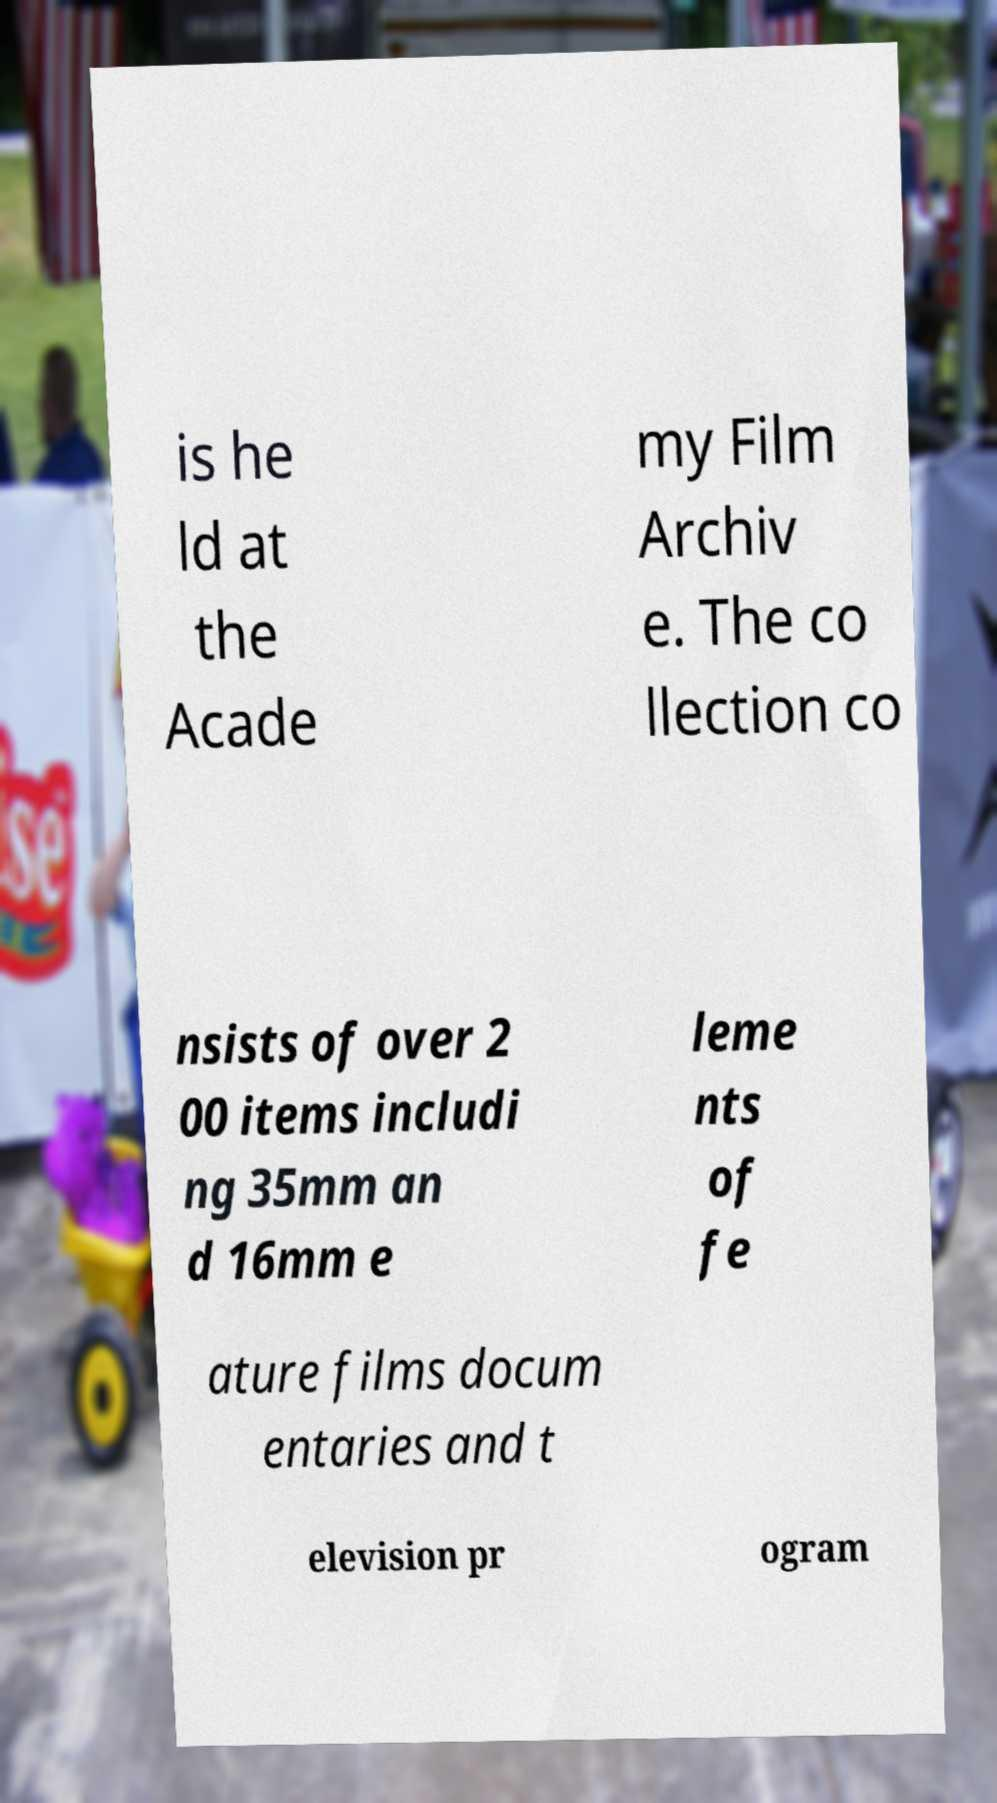There's text embedded in this image that I need extracted. Can you transcribe it verbatim? is he ld at the Acade my Film Archiv e. The co llection co nsists of over 2 00 items includi ng 35mm an d 16mm e leme nts of fe ature films docum entaries and t elevision pr ogram 